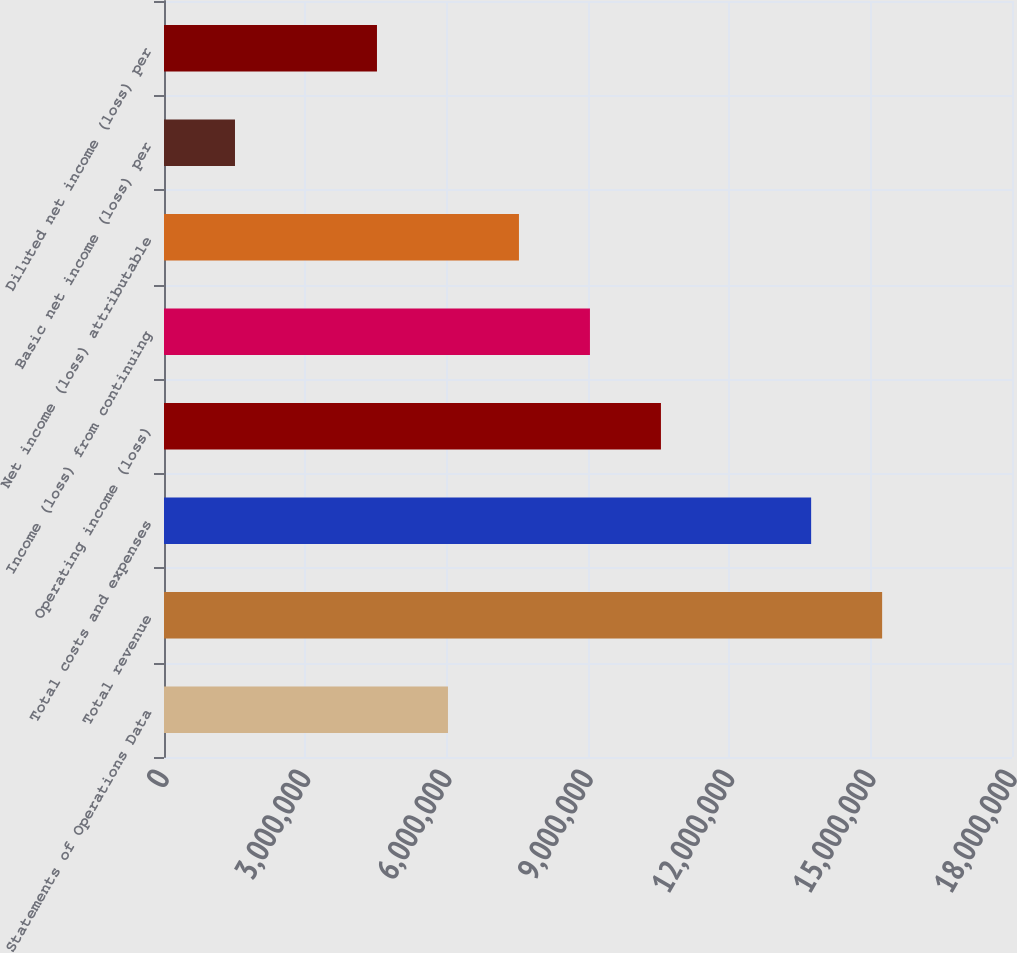<chart> <loc_0><loc_0><loc_500><loc_500><bar_chart><fcel>Statements of Operations Data<fcel>Total revenue<fcel>Total costs and expenses<fcel>Operating income (loss)<fcel>Income (loss) from continuing<fcel>Net income (loss) attributable<fcel>Basic net income (loss) per<fcel>Diluted net income (loss) per<nl><fcel>6.02756e+06<fcel>1.52434e+07<fcel>1.37365e+07<fcel>1.05482e+07<fcel>9.04134e+06<fcel>7.53445e+06<fcel>1.50689e+06<fcel>4.52067e+06<nl></chart> 